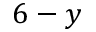<formula> <loc_0><loc_0><loc_500><loc_500>6 - y</formula> 